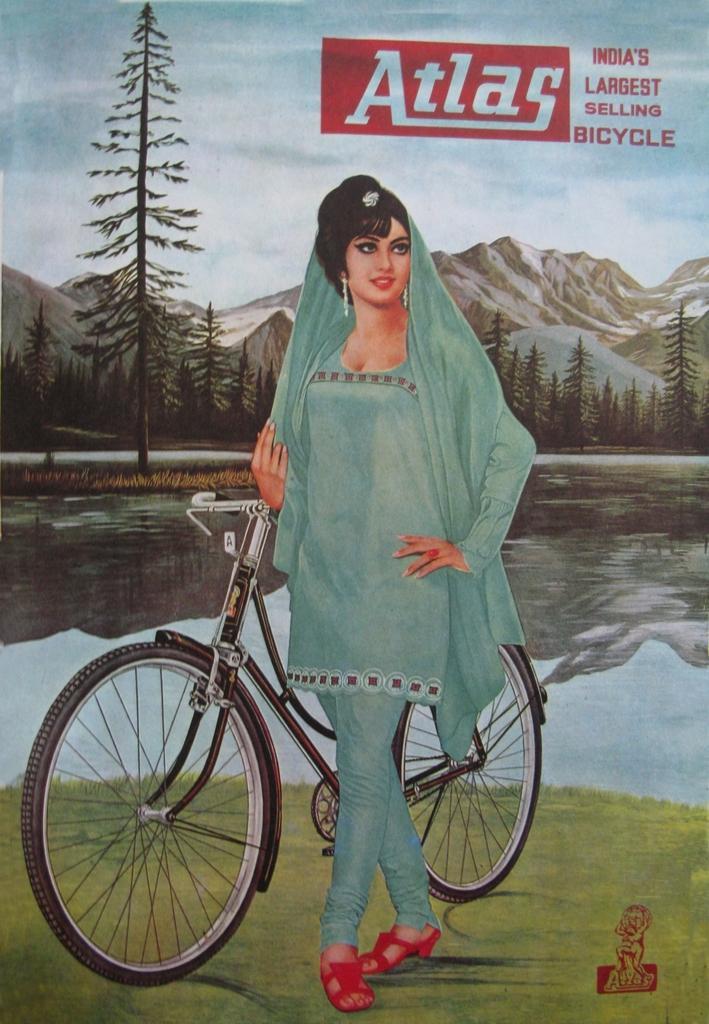In one or two sentences, can you explain what this image depicts? In this image we can see a poster with text and image of a woman standing near the bicycle on the ground and in the background there is water, trees, mountains and the sky. 